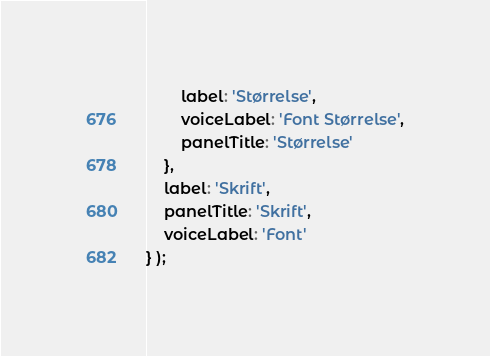<code> <loc_0><loc_0><loc_500><loc_500><_JavaScript_>		label: 'Størrelse',
		voiceLabel: 'Font Størrelse',
		panelTitle: 'Størrelse'
	},
	label: 'Skrift',
	panelTitle: 'Skrift',
	voiceLabel: 'Font'
} );
</code> 